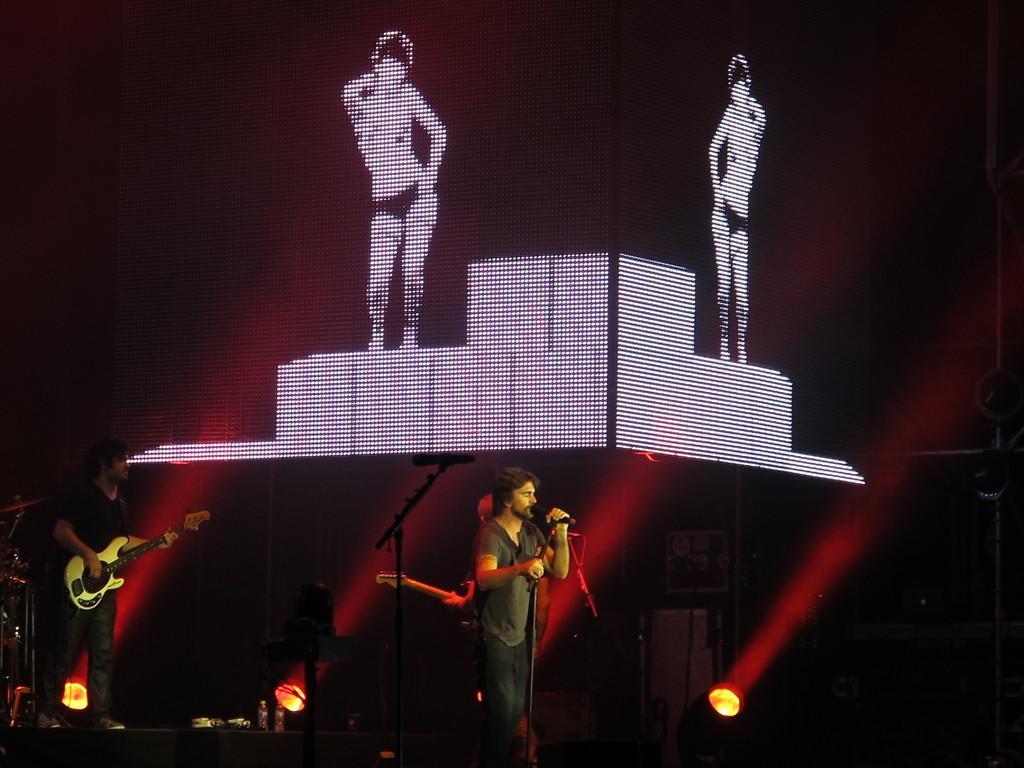In one or two sentences, can you explain what this image depicts? In this image I can see three persons are standing on the stage and playing musical instruments. In the background I can see focus lights, graphics and a curtain. This image is taken on the stage. 